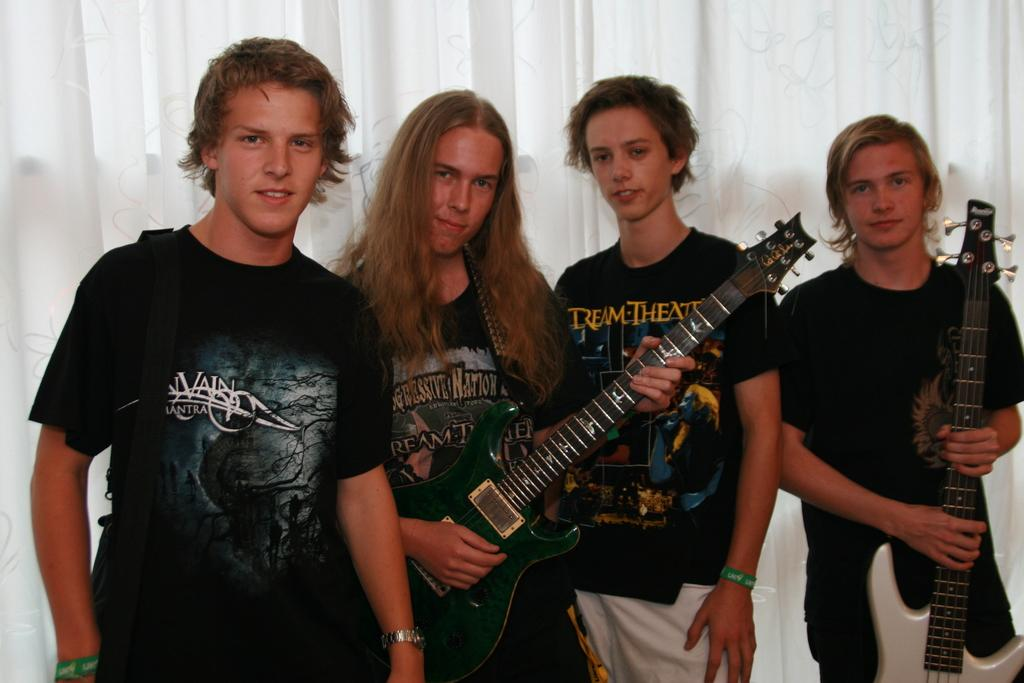How many people are in the image? There are four men in the image. What are two of the men holding? Two of the men are holding guitars. What is the facial expression of the men in the image? The men are smiling. What can be seen in the background of the image? There is a white color curtain in the background of the image. What type of tax is being discussed by the men in the image? There is no indication in the image that the men are discussing any type of tax. 